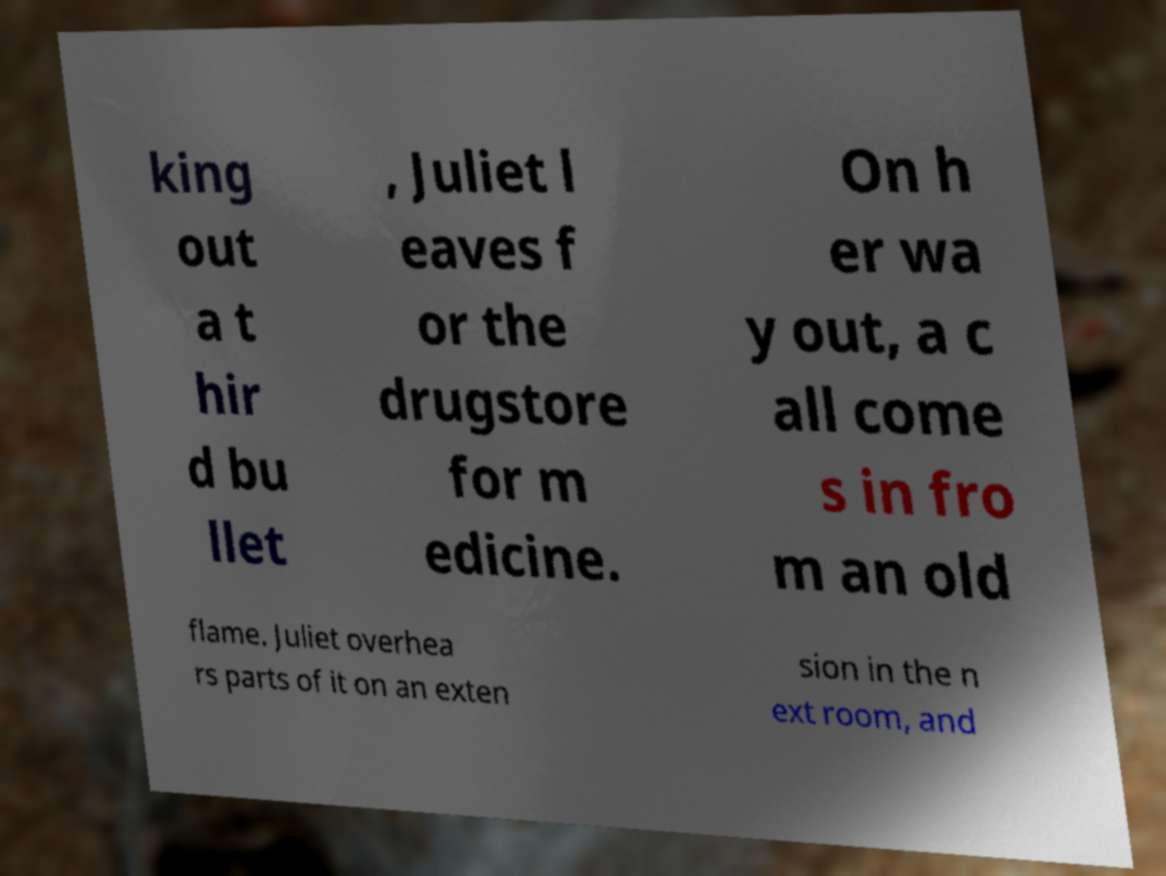Please read and relay the text visible in this image. What does it say? king out a t hir d bu llet , Juliet l eaves f or the drugstore for m edicine. On h er wa y out, a c all come s in fro m an old flame. Juliet overhea rs parts of it on an exten sion in the n ext room, and 